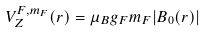<formula> <loc_0><loc_0><loc_500><loc_500>V _ { Z } ^ { F , m _ { F } } ( r ) = \mu _ { B } g _ { F } m _ { F } | B _ { 0 } ( r ) |</formula> 